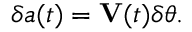Convert formula to latex. <formula><loc_0><loc_0><loc_500><loc_500>\delta a ( t ) = V ( t ) \delta \theta .</formula> 